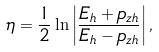<formula> <loc_0><loc_0><loc_500><loc_500>\eta = \frac { 1 } { 2 } \ln \left | \frac { E _ { h } + p _ { z h } } { E _ { h } - p _ { z h } } \right | ,</formula> 